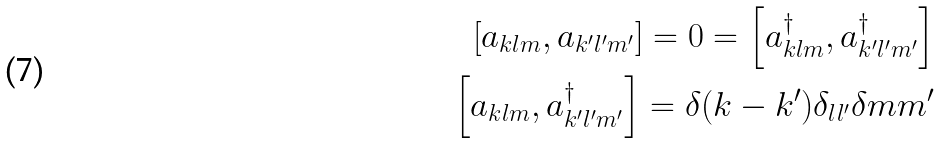<formula> <loc_0><loc_0><loc_500><loc_500>\left [ a _ { k l m } , a _ { k ^ { \prime } l ^ { \prime } m ^ { \prime } } \right ] = 0 = \left [ a ^ { \dagger } _ { k l m } , a ^ { \dagger } _ { k ^ { \prime } l ^ { \prime } m ^ { \prime } } \right ] \\ \left [ a _ { k l m } , a ^ { \dagger } _ { k ^ { \prime } l ^ { \prime } m ^ { \prime } } \right ] = \delta ( k - k ^ { \prime } ) \delta _ { l l ^ { \prime } } \delta { m m ^ { \prime } }</formula> 